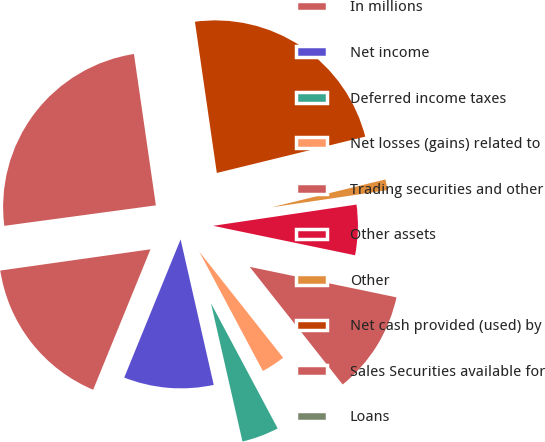Convert chart. <chart><loc_0><loc_0><loc_500><loc_500><pie_chart><fcel>In millions<fcel>Net income<fcel>Deferred income taxes<fcel>Net losses (gains) related to<fcel>Trading securities and other<fcel>Other assets<fcel>Other<fcel>Net cash provided (used) by<fcel>Sales Securities available for<fcel>Loans<nl><fcel>16.6%<fcel>9.73%<fcel>4.23%<fcel>2.85%<fcel>11.1%<fcel>5.6%<fcel>1.48%<fcel>23.47%<fcel>24.85%<fcel>0.1%<nl></chart> 